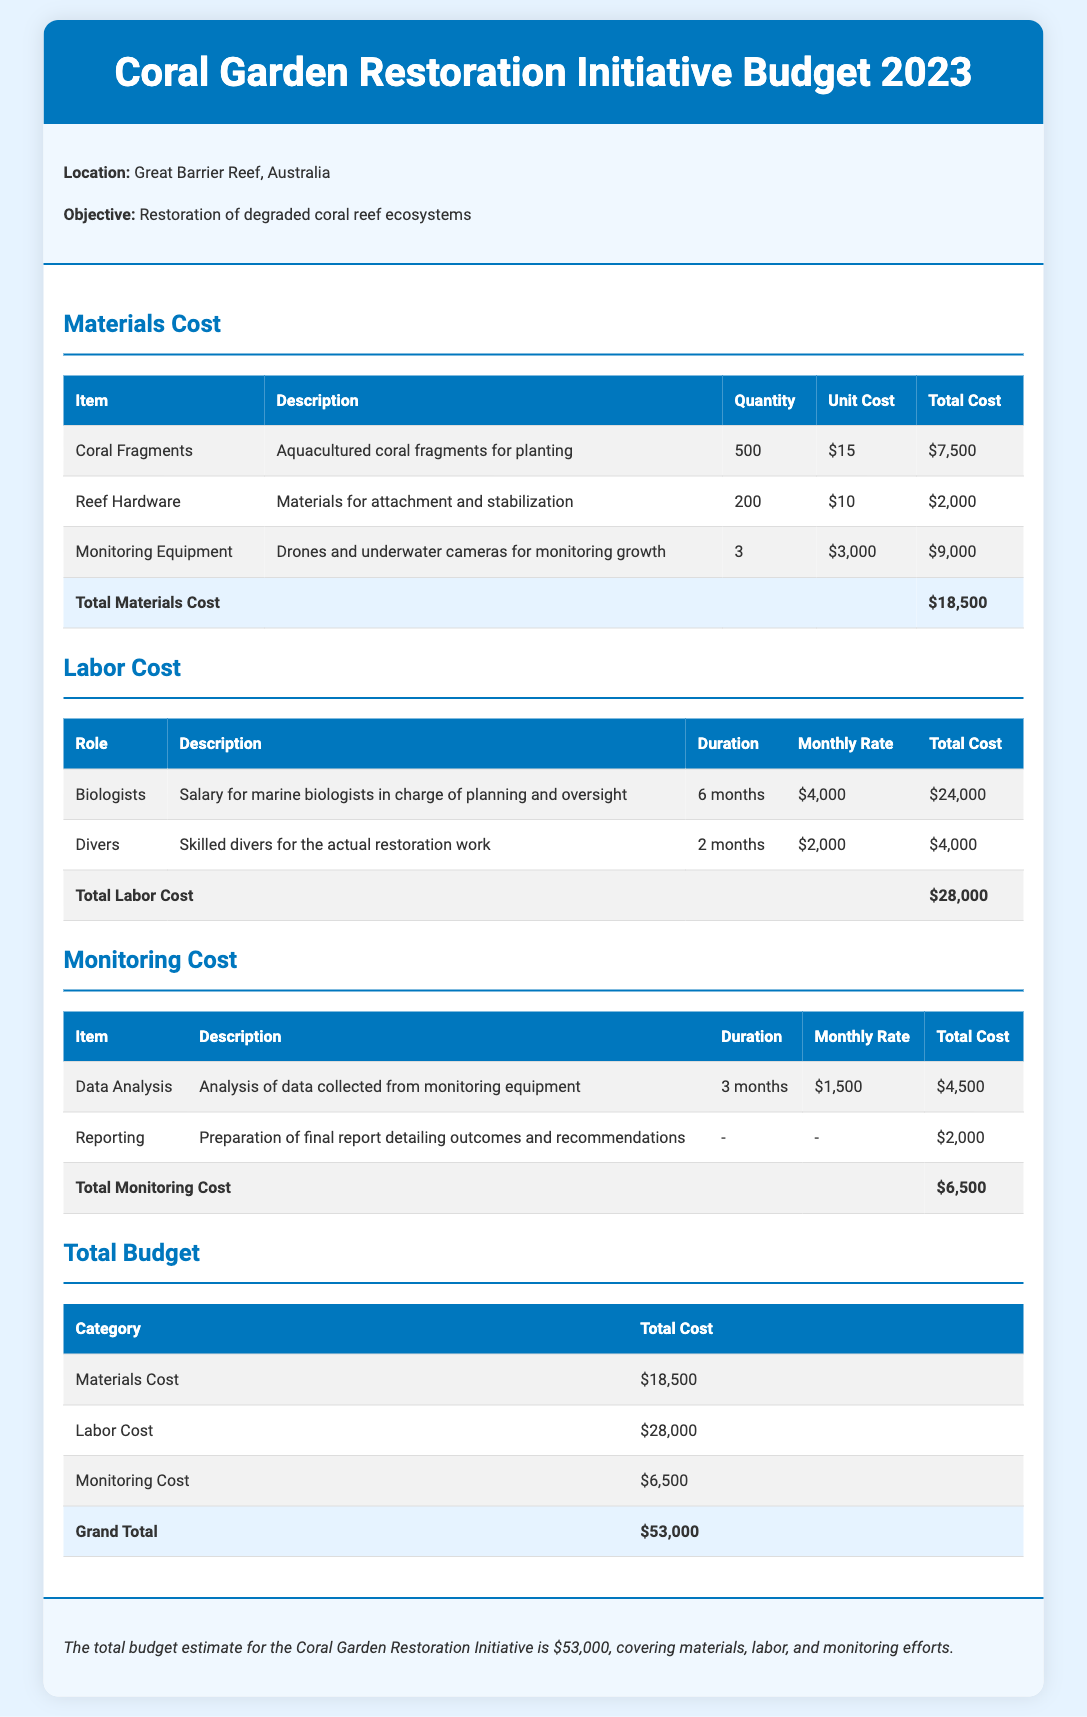What is the total materials cost? The total materials cost is listed in the document and sums up to $18,500.
Answer: $18,500 How many coral fragments will be used? The document states that 500 coral fragments will be used for planting.
Answer: 500 What is the monthly rate for biologists? The monthly rate for biologists is specified in the labor cost section and is $4,000.
Answer: $4,000 What is the grand total budget? The grand total budget is found by adding all costs together, which amounts to $53,000.
Answer: $53,000 What type of equipment is used for monitoring growth? The document lists drones and underwater cameras as the equipment used for monitoring growth.
Answer: Drones and underwater cameras How long will the data analysis last? The duration of the data analysis is mentioned as 3 months in the monitoring cost section.
Answer: 3 months What is the total labor cost? The total labor cost is provided in the document and totals $28,000.
Answer: $28,000 What type of report will be prepared? The document describes the preparation of a final report detailing outcomes and recommendations.
Answer: Final report 